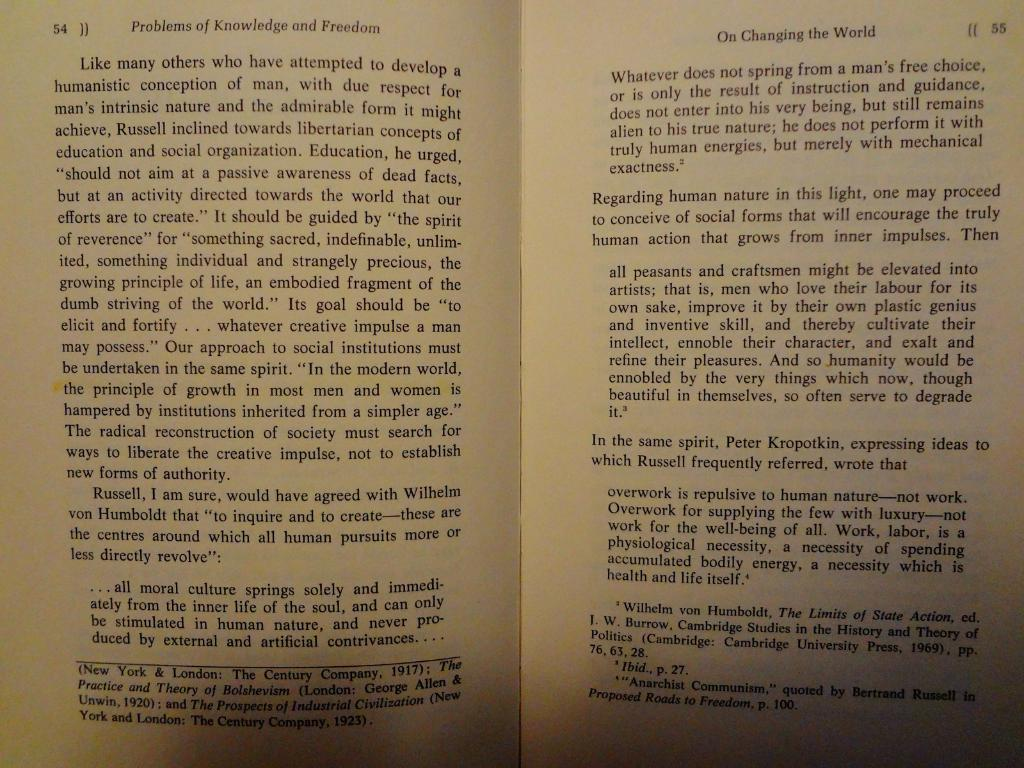<image>
Summarize the visual content of the image. A book called Problems of Knowledge and Freedom opened to page 54 and 55. 